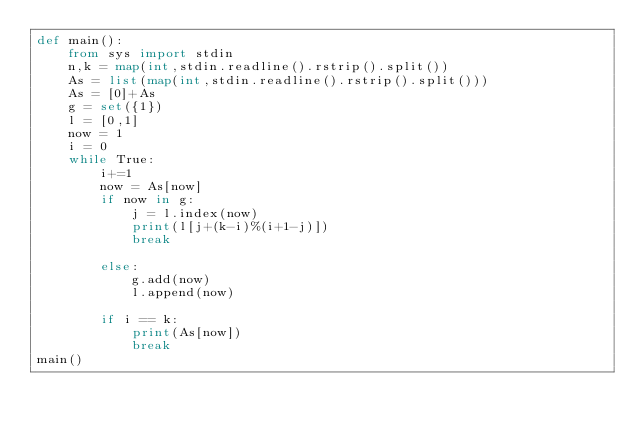Convert code to text. <code><loc_0><loc_0><loc_500><loc_500><_Python_>def main():
    from sys import stdin
    n,k = map(int,stdin.readline().rstrip().split())
    As = list(map(int,stdin.readline().rstrip().split()))
    As = [0]+As
    g = set({1})
    l = [0,1]
    now = 1
    i = 0
    while True:
        i+=1
        now = As[now]
        if now in g:
            j = l.index(now)
            print(l[j+(k-i)%(i+1-j)])
            break
            
        else:
            g.add(now)
            l.append(now)
        
        if i == k:
            print(As[now])
            break
main()</code> 